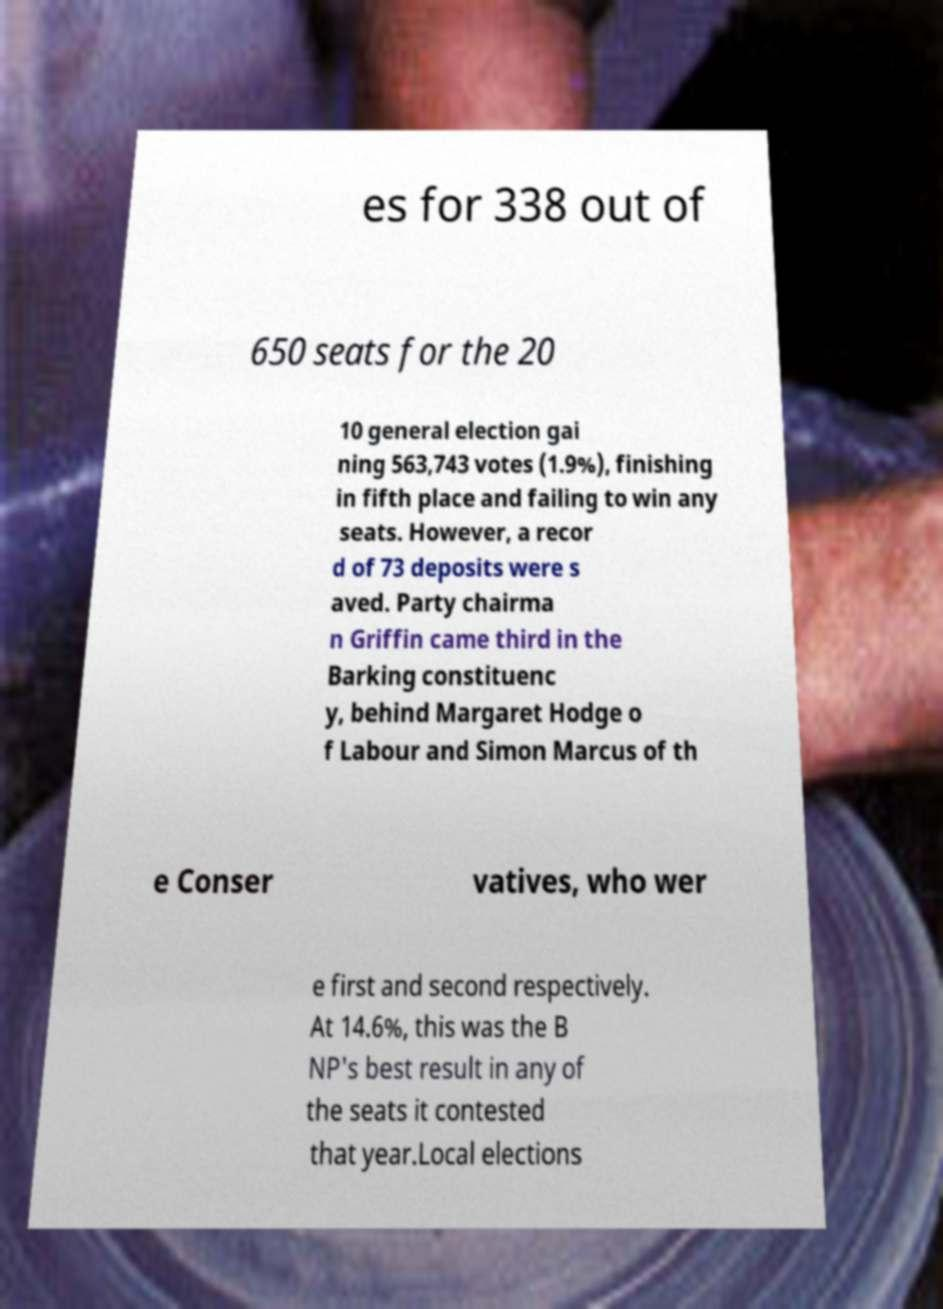Could you extract and type out the text from this image? es for 338 out of 650 seats for the 20 10 general election gai ning 563,743 votes (1.9%), finishing in fifth place and failing to win any seats. However, a recor d of 73 deposits were s aved. Party chairma n Griffin came third in the Barking constituenc y, behind Margaret Hodge o f Labour and Simon Marcus of th e Conser vatives, who wer e first and second respectively. At 14.6%, this was the B NP's best result in any of the seats it contested that year.Local elections 